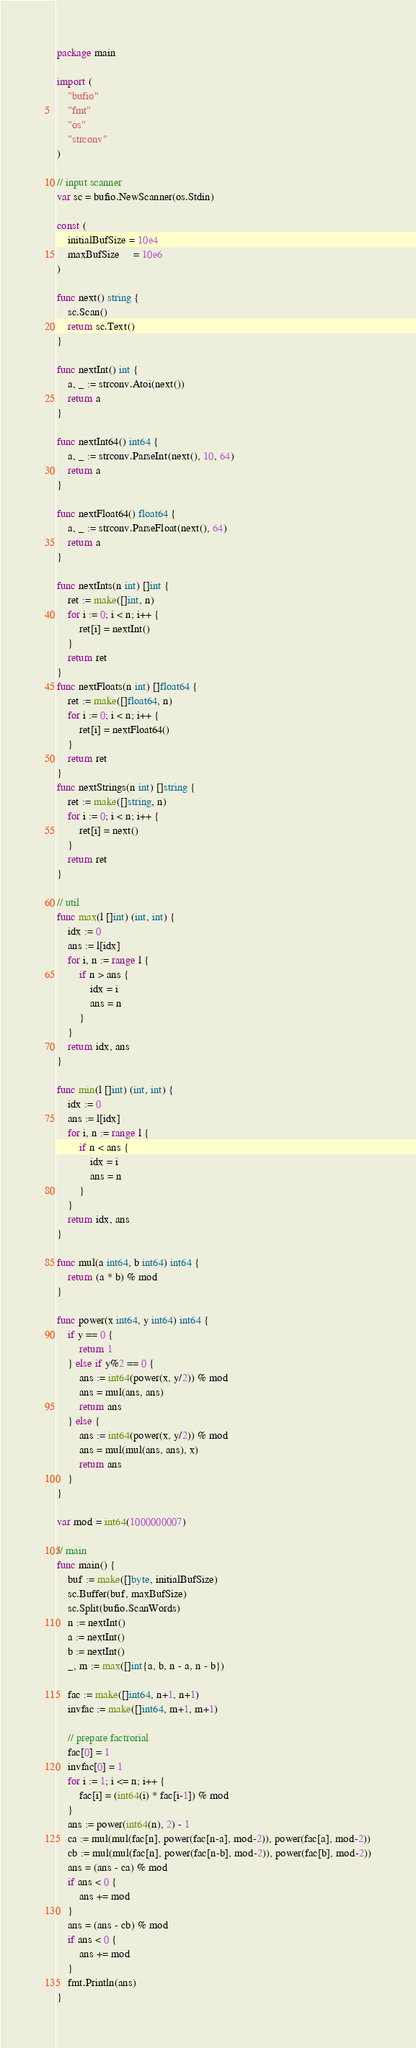Convert code to text. <code><loc_0><loc_0><loc_500><loc_500><_Go_>package main

import (
	"bufio"
	"fmt"
	"os"
	"strconv"
)

// input scanner
var sc = bufio.NewScanner(os.Stdin)

const (
	initialBufSize = 10e4
	maxBufSize     = 10e6
)

func next() string {
	sc.Scan()
	return sc.Text()
}

func nextInt() int {
	a, _ := strconv.Atoi(next())
	return a
}

func nextInt64() int64 {
	a, _ := strconv.ParseInt(next(), 10, 64)
	return a
}

func nextFloat64() float64 {
	a, _ := strconv.ParseFloat(next(), 64)
	return a
}

func nextInts(n int) []int {
	ret := make([]int, n)
	for i := 0; i < n; i++ {
		ret[i] = nextInt()
	}
	return ret
}
func nextFloats(n int) []float64 {
	ret := make([]float64, n)
	for i := 0; i < n; i++ {
		ret[i] = nextFloat64()
	}
	return ret
}
func nextStrings(n int) []string {
	ret := make([]string, n)
	for i := 0; i < n; i++ {
		ret[i] = next()
	}
	return ret
}

// util
func max(l []int) (int, int) {
	idx := 0
	ans := l[idx]
	for i, n := range l {
		if n > ans {
			idx = i
			ans = n
		}
	}
	return idx, ans
}

func min(l []int) (int, int) {
	idx := 0
	ans := l[idx]
	for i, n := range l {
		if n < ans {
			idx = i
			ans = n
		}
	}
	return idx, ans
}

func mul(a int64, b int64) int64 {
	return (a * b) % mod
}

func power(x int64, y int64) int64 {
	if y == 0 {
		return 1
	} else if y%2 == 0 {
		ans := int64(power(x, y/2)) % mod
		ans = mul(ans, ans)
		return ans
	} else {
		ans := int64(power(x, y/2)) % mod
		ans = mul(mul(ans, ans), x)
		return ans
	}
}

var mod = int64(1000000007)

// main
func main() {
	buf := make([]byte, initialBufSize)
	sc.Buffer(buf, maxBufSize)
	sc.Split(bufio.ScanWords)
	n := nextInt()
	a := nextInt()
	b := nextInt()
	_, m := max([]int{a, b, n - a, n - b})

	fac := make([]int64, n+1, n+1)
	invfac := make([]int64, m+1, m+1)

	// prepare factrorial
	fac[0] = 1
	invfac[0] = 1
	for i := 1; i <= n; i++ {
		fac[i] = (int64(i) * fac[i-1]) % mod
	}
	ans := power(int64(n), 2) - 1
	ca := mul(mul(fac[n], power(fac[n-a], mod-2)), power(fac[a], mod-2))
	cb := mul(mul(fac[n], power(fac[n-b], mod-2)), power(fac[b], mod-2))
	ans = (ans - ca) % mod
	if ans < 0 {
		ans += mod
	}
	ans = (ans - cb) % mod
	if ans < 0 {
		ans += mod
	}
	fmt.Println(ans)
}
</code> 